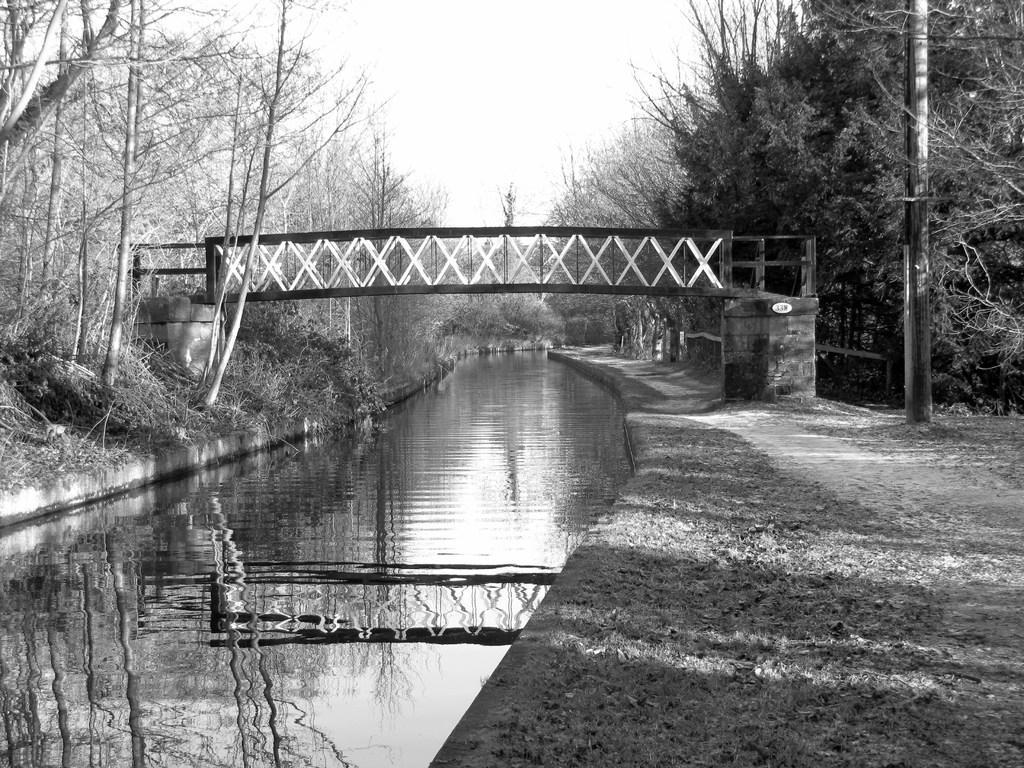What can be seen on both sides of the image? There is water on both sides of the image. What is located near the water? There is a path and plants near the water. What type of vegetation is visible near the water? Trees are visible near the water. What structure is present over the water? There is a bridge with a railing over the water. What is visible in the background of the image? The sky is visible in the background of the image. What type of hammer can be seen near the water in the image? There is no hammer present in the image. What color are the toes of the person standing near the water? There is no person or toes visible in the image. 